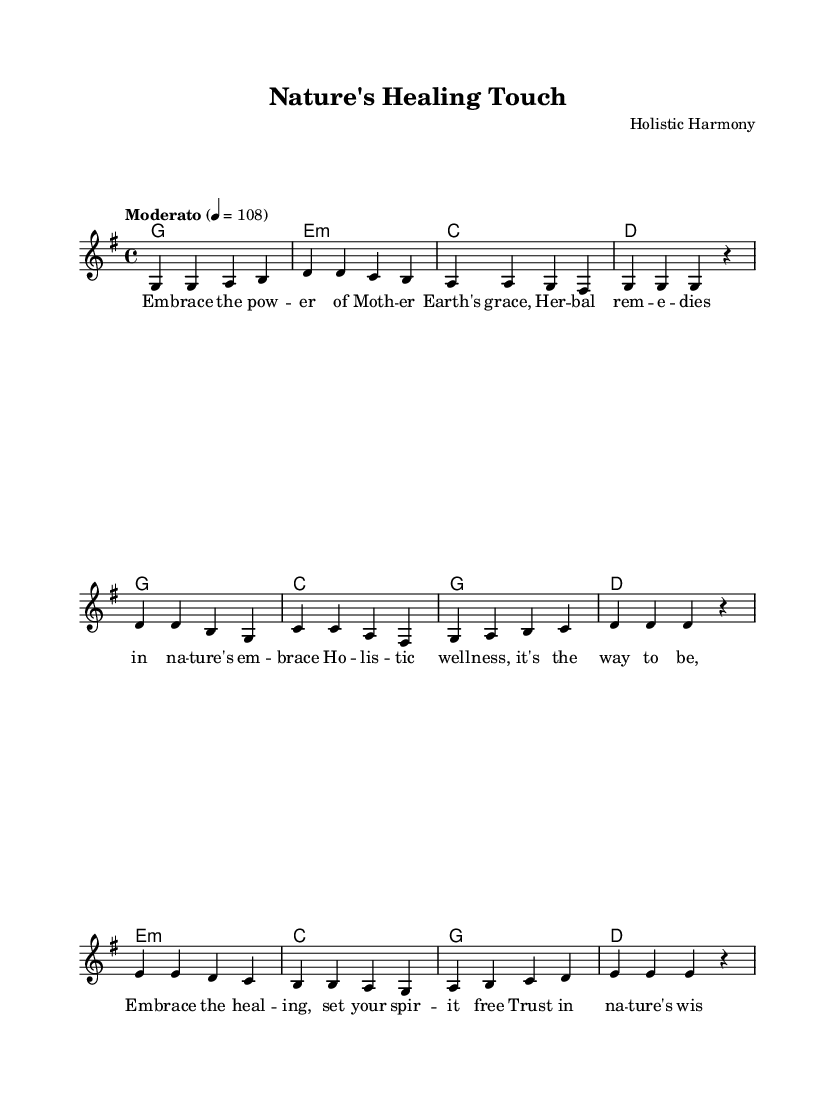What is the key signature of this music? The key signature is G major, which has one sharp (F#). This is determined by the "g" in the global section of the code, where it states \key g \major.
Answer: G major What is the time signature of this music? The time signature is 4/4, indicative of four beats per measure. This information is found in the global section of the code with the notation \time 4/4.
Answer: 4/4 What is the tempo indication for this piece? The tempo indication is Moderato at a speed of 108 beats per minute. This can be found in the global section of the code marked by \tempo "Moderato" 4 = 108.
Answer: Moderato 108 What type of chords are used in the harmony section? The harmony section features major and minor chords. This can be concluded by looking at the chord notation where "g", "e:m", "c", and "d" appear, indicating the operational major/minor structure of chords.
Answer: Major and minor What is the theme of the lyrics in this composition? The theme centers around holistic wellness and natural remedies. This can be inferred from the lyrics which discuss embracing nature's wisdom and healing. The phrases within the verse explicitly mention "Mother Earth's grace" and avoiding artificial remedies.
Answer: Holistic wellness What is the structure of the song based on the provided data? The structure of the song consists of a verse, a chorus, and a bridge. This can be understood by identifying the distinct melodic sections labeled in the melody part and matching them with the lyrics and chords arrangement.
Answer: Verse, chorus, bridge 